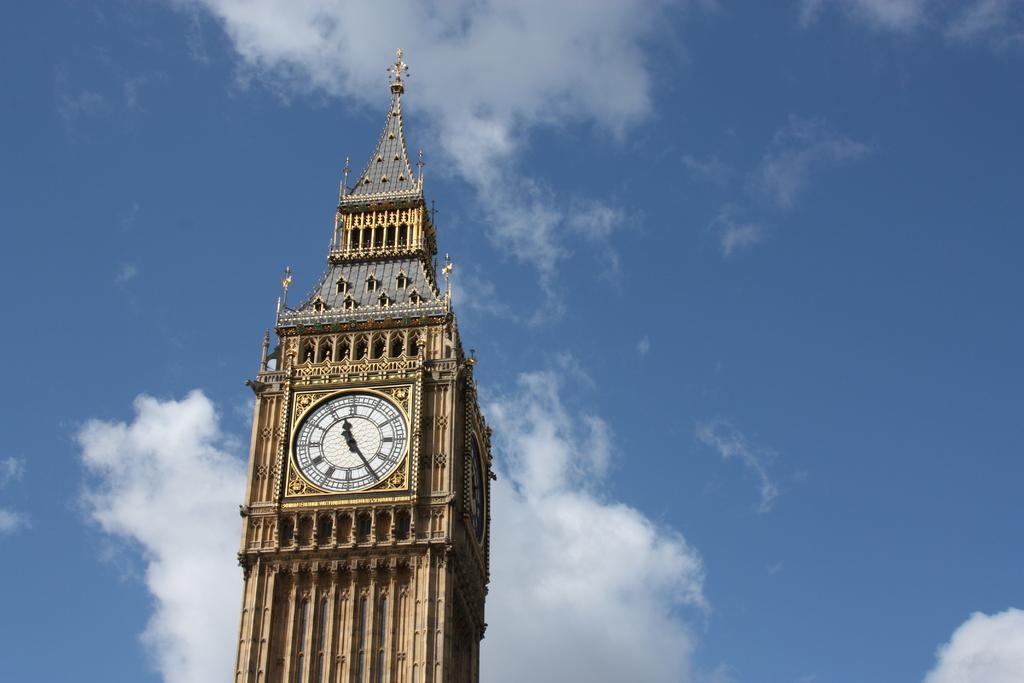What structure is the main subject of the image? There is a building in the image. What feature can be seen on the building? The building has a clock on it. What can be seen in the background of the image? The sky is visible in the background of the image. How would you describe the weather based on the sky in the image? The sky appears to be cloudy, which might suggest overcast or potentially rainy weather. What type of cub is playing with a bead in the image? There is no cub or bead present in the image. How does the hair on the building look in the image? There is no hair on the building in the image; it is a structure made of materials like brick, concrete, or glass. 